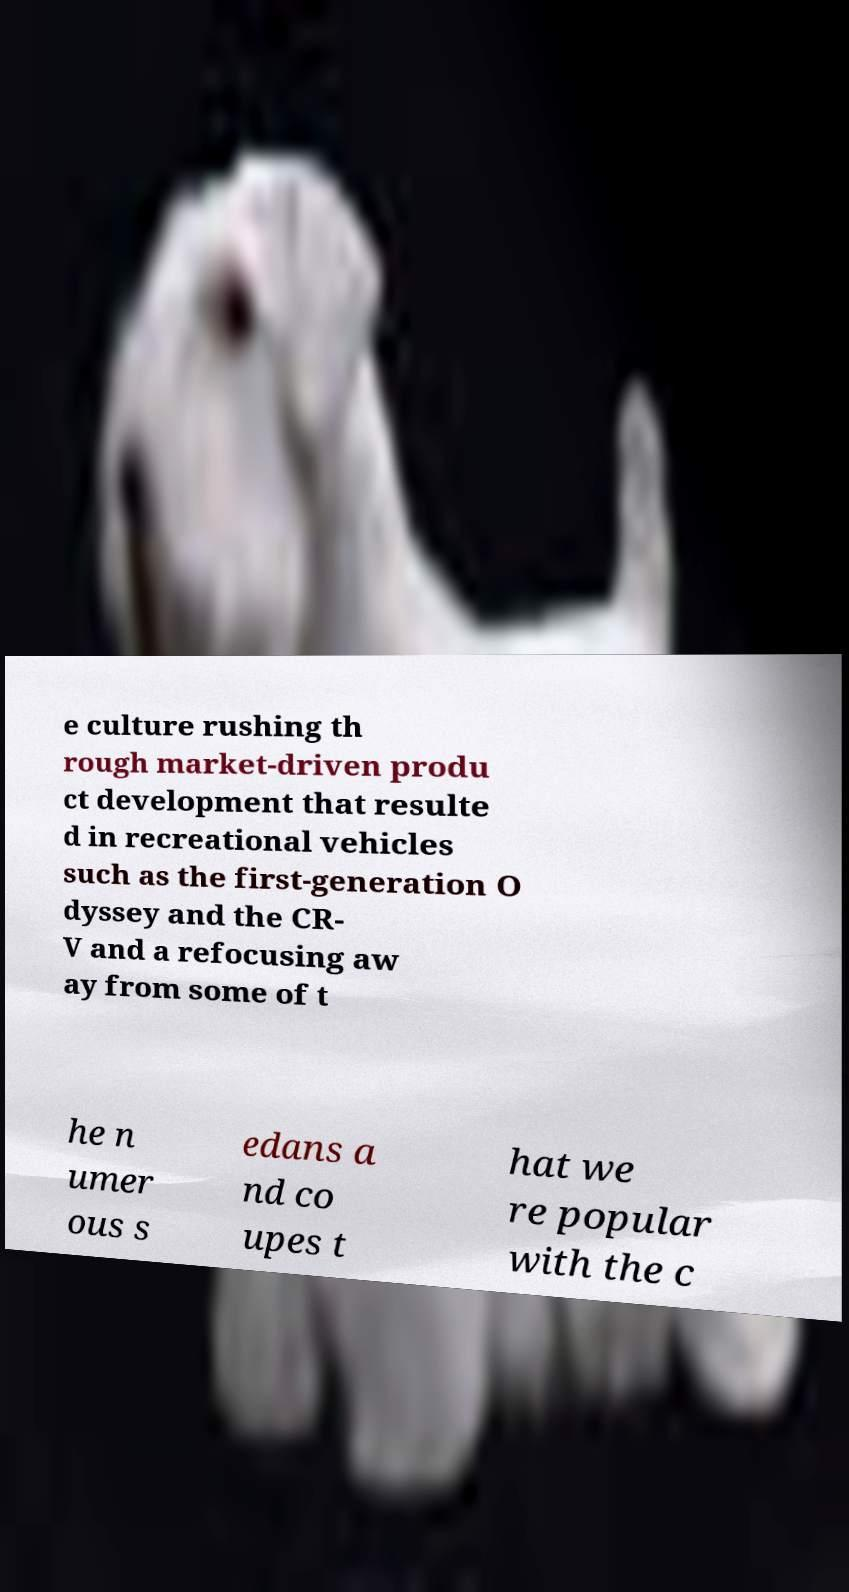Could you assist in decoding the text presented in this image and type it out clearly? e culture rushing th rough market-driven produ ct development that resulte d in recreational vehicles such as the first-generation O dyssey and the CR- V and a refocusing aw ay from some of t he n umer ous s edans a nd co upes t hat we re popular with the c 